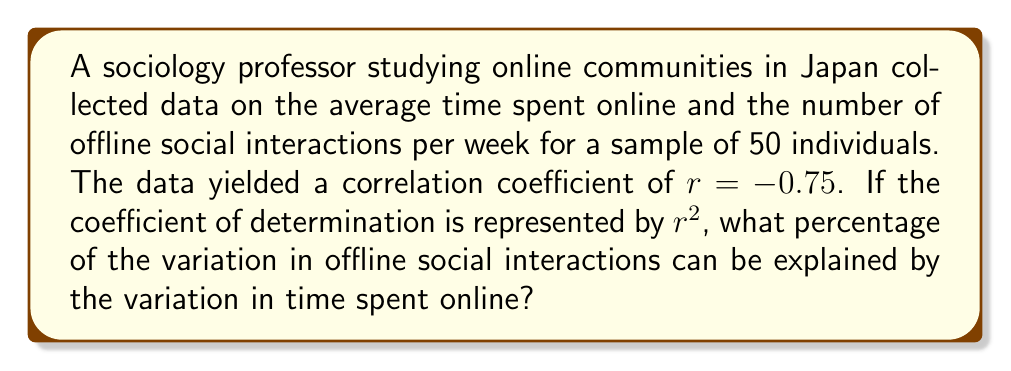Give your solution to this math problem. To solve this problem, we'll follow these steps:

1) Recall that the coefficient of determination, $r^2$, represents the proportion of the variance in the dependent variable that is predictable from the independent variable.

2) We're given the correlation coefficient $r = -0.75$. The sign of the correlation coefficient indicates a negative relationship, but it doesn't affect the calculation of $r^2$.

3) To find $r^2$, we simply square the correlation coefficient:

   $r^2 = (-0.75)^2 = 0.5625$

4) To convert this to a percentage, we multiply by 100:

   $0.5625 \times 100 = 56.25\%$

This means that 56.25% of the variation in offline social interactions can be explained by the variation in time spent online.

5) This result suggests a moderately strong relationship between online time and offline interactions in the studied Japanese community, which could be valuable for the sociology professor's research on the impact of online communities on modern Japanese society.
Answer: 56.25% 